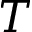<formula> <loc_0><loc_0><loc_500><loc_500>T</formula> 